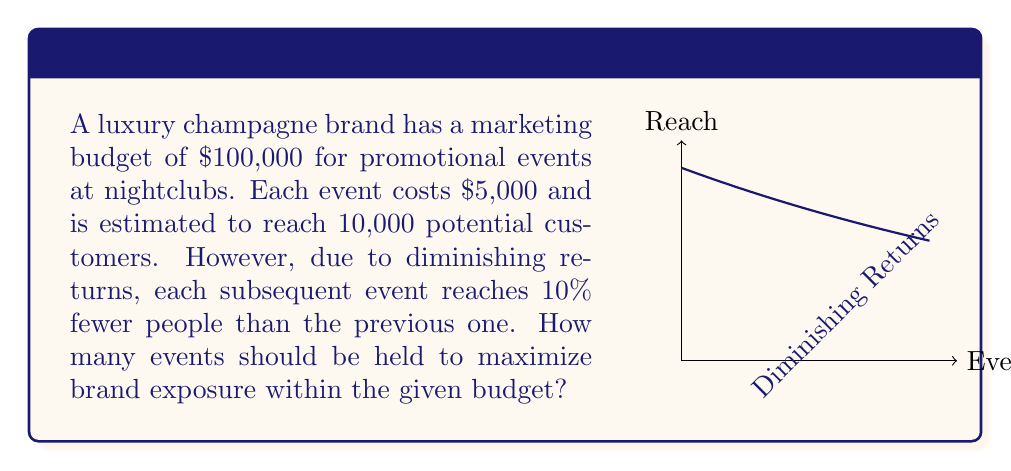Give your solution to this math problem. Let's approach this step-by-step:

1) Let $n$ be the number of events.

2) The budget constraint is:
   $$5000n \leq 100000$$
   $$n \leq 20$$

3) The reach of each event can be modeled as:
   $$R_i = 10000 \cdot (0.9)^{i-1}$$
   where $R_i$ is the reach of the $i$-th event.

4) The total reach for $n$ events is:
   $$T(n) = \sum_{i=1}^n R_i = 10000 \sum_{i=1}^n (0.9)^{i-1}$$

5) This is a geometric series with first term $a=10000$ and common ratio $r=0.9$. The sum of this series is:
   $$T(n) = a\frac{1-r^n}{1-r} = 10000\frac{1-0.9^n}{1-0.9} = 100000(1-0.9^n)$$

6) To find the maximum, we can differentiate $T(n)$ with respect to $n$:
   $$\frac{dT}{dn} = 100000 \cdot (-\ln(0.9)) \cdot 0.9^n$$

7) Setting this to zero:
   $$100000 \cdot (-\ln(0.9)) \cdot 0.9^n = 0$$
   This is never zero for finite $n$, meaning the function is always increasing.

8) Given our budget constraint of $n \leq 20$, the maximum reach will be achieved at $n = 20$ events.
Answer: 20 events 